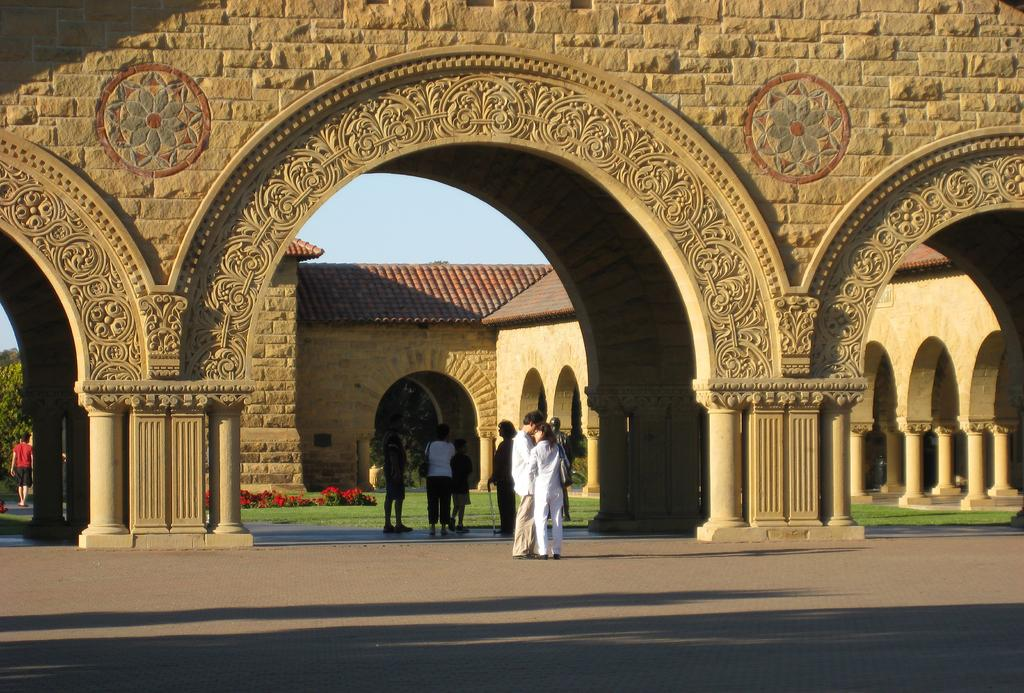What architectural feature can be seen in the image? There are arches in the image. What is the presence of people in the image suggest? There are people standing in the image, which suggests that there might be an event or gathering taking place. What is happening in the background of the image? A human is walking in the background of the image. What type of vegetation is present in the image? Trees and plants with flowers are present in the image. What is the condition of the ground in the image? Grass is visible on the ground. What is the color of the sky in the image? The sky is blue in the image. What type of jelly can be seen on the arches in the image? There is no jelly present on the arches in the image; they are architectural features made of stone or other materials. Can you provide an example of a comforting activity that can be seen in the image? There is no specific activity depicted in the image that can be described as comforting; it simply shows arches, people, a walking human, trees, plants with flowers, grass, and a blue sky. 